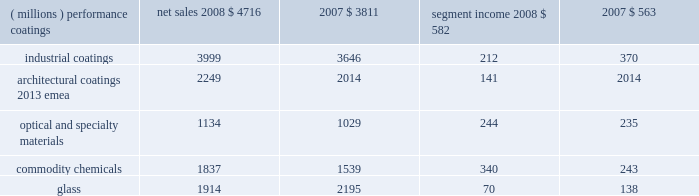Management 2019s discussion and analysis results of reportable business segments net sales segment income ( millions ) 2008 2007 2008 2007 .
Performance coatings sales increased $ 905 million or 24% ( 24 % ) in 2008 .
Sales increased 21% ( 21 % ) due to acquisitions , largely due to the impact of the sigmakalon protective and marine coatings business .
Sales also grew by 3% ( 3 % ) due to higher selling prices and 2% ( 2 % ) due to the positive impact of foreign currency translation .
Sales volumes declined 2% ( 2 % ) as reduced volumes in architectural coatings 2013 americas and asia pacific and automotive refinish were not fully offset by improved volumes in the aerospace and protective and marine businesses .
Volume growth in the aerospace businesses occurred throughout the world , while the volume growth in protective and marine coatings occurred primarily in asia .
Segment income increased $ 19 million in 2008 .
Factors increasing segment income were the positive impact of acquisitions , lower overhead costs and the positive impact of foreign currency translation .
The benefit of higher selling prices more than offset the negative impact of inflation , including higher raw materials and benefit costs .
Segment income was reduced by the impact of the lower sales volumes in architectural coatings and automotive refinish , which more than offset the benefit of volume gains in the aerospace and protective and marine coatings businesses .
Industrial coatings sales increased $ 353 million or 10% ( 10 % ) in 2008 .
Sales increased 11% ( 11 % ) due to acquisitions , including the impact of the sigmakalon industrial coatings business .
Sales also grew 3% ( 3 % ) due to the positive impact of foreign currency translation , and 1% ( 1 % ) from higher selling prices .
Sales volumes declined 5% ( 5 % ) as reduced volumes were experienced in all three businesses , reflecting the substantial declines in global demand .
Volume declines in the automotive and industrial businesses were primarily in the u.s .
And canada .
Additional volume declines in the european and asian regions were experienced by the industrial coatings business .
In packaging coatings , volume declines in europe were only partially offset by gains in asia and north america .
Segment income declined $ 158 million in 2008 due to the lower volumes and inflation , including higher raw material and freight costs , the impact of which was only partially mitigated by the increased selling prices .
Segment income also declined due to higher selling and distribution costs , including higher bad debt expense .
Factors increasing segment income were the earnings of acquired businesses , the positive impact of foreign currency translation and lower manufacturing costs .
Architectural coatings - emea sales for the year were $ 2249 million .
This business was acquired in the sigmakalon acquisition .
Segment income was $ 141 million , which included amortization expense of $ 63 million related to acquired intangible assets and depreciation expense of $ 58 million .
Optical and specialty materials sales increased $ 105 million or 10% ( 10 % ) in 2008 .
Sales increased 5% ( 5 % ) due to higher volumes in our optical products business resulting from the launch of transitions optical 2019s next generation lens product , 3% ( 3 % ) due to the positive impact of foreign currency translation and 2% ( 2 % ) due to increased selling prices .
Segment income increased $ 9 million in 2008 .
The increase in segment income was the result of increased sales volumes and the favorable impact of currency partially offset by increased selling and marketing costs in the optical products business related to the transitions optical product launch mentioned above .
Increased selling prices only partially offset higher raw material costs , primarily in our silicas business .
Commodity chemicals sales increased $ 298 million or 19% ( 19 % ) in 2008 .
Sales increased 18% ( 18 % ) due to higher selling prices and 1% ( 1 % ) due to improved sales volumes .
Segment income increased $ 97 million in 2008 .
Segment income increased in large part due to higher selling prices , which more than offset the negative impact of inflation , primarily higher raw material and energy costs .
Segment income also improved due to lower manufacturing costs , while lower margin mix and equity earnings reduced segment income .
Glass sales decreased $ 281 million or 13% ( 13 % ) in 2008 .
Sales decreased 11% ( 11 % ) due to the divestiture of the automotive glass and services business in september 2008 and 4% ( 4 % ) due to lower sales volumes .
Sales increased 2% ( 2 % ) due to higher selling prices .
Segment income decreased $ 68 million in 2008 .
Segment income decreased due to the divestiture of the automotive glass and services business , lower volumes , the negative impact of inflation and lower equity earnings from our asian fiber glass joint ventures .
Factors increasing segment income were lower manufacturing costs , higher selling prices and stronger foreign currency .
Outlook overall global economic activity was volatile in 2008 with an overall downward trend .
The north american economy continued a slowing trend which began during the second half of 2006 and continued all of 2007 .
The impact of the weakening u.s .
Economy was particularly 2008 ppg annual report and form 10-k 17 .
What was the revenue impact of higher selling prices in the glass segment in 2008? 
Computations: ((2195 * 2%) * 1000000)
Answer: 43900000.0. 